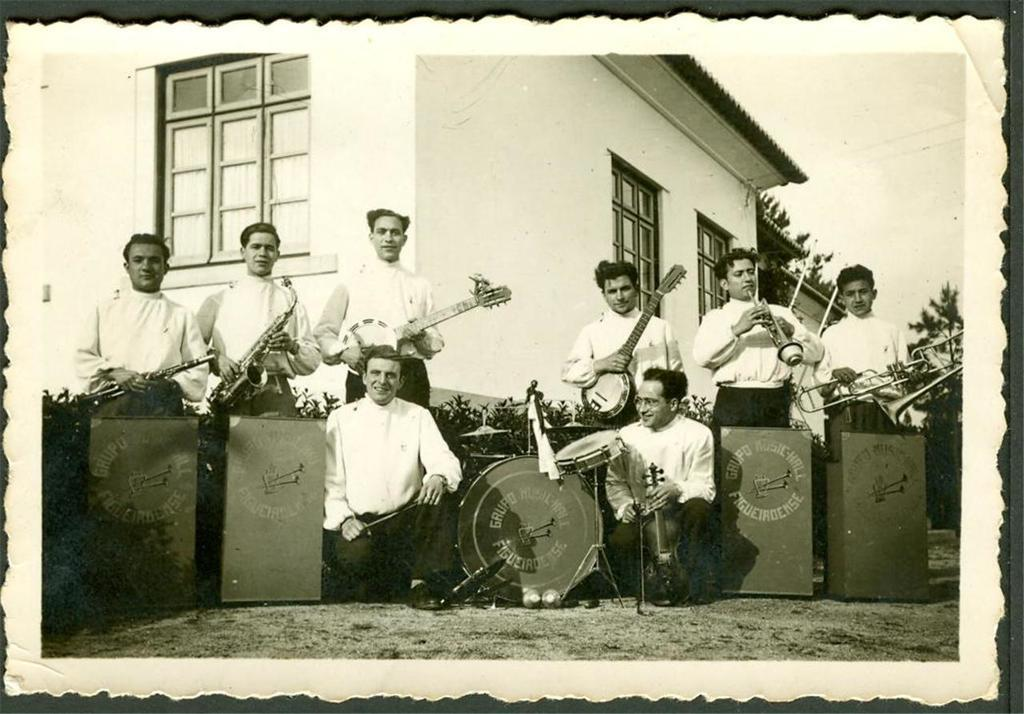What are the people in the image doing? The people in the image are standing and holding musical instruments. What type of structure is visible in the image? There is a building in the image. What architectural feature can be seen on the building? There are glass windows on the building. What other objects are present in the image? There are boards and trees in the image. What type of waste or pollution can be seen in the image? There is no waste or pollution visible in the image; it is in black and white and focuses on people with musical instruments, a building, glass windows, boards, and trees. 